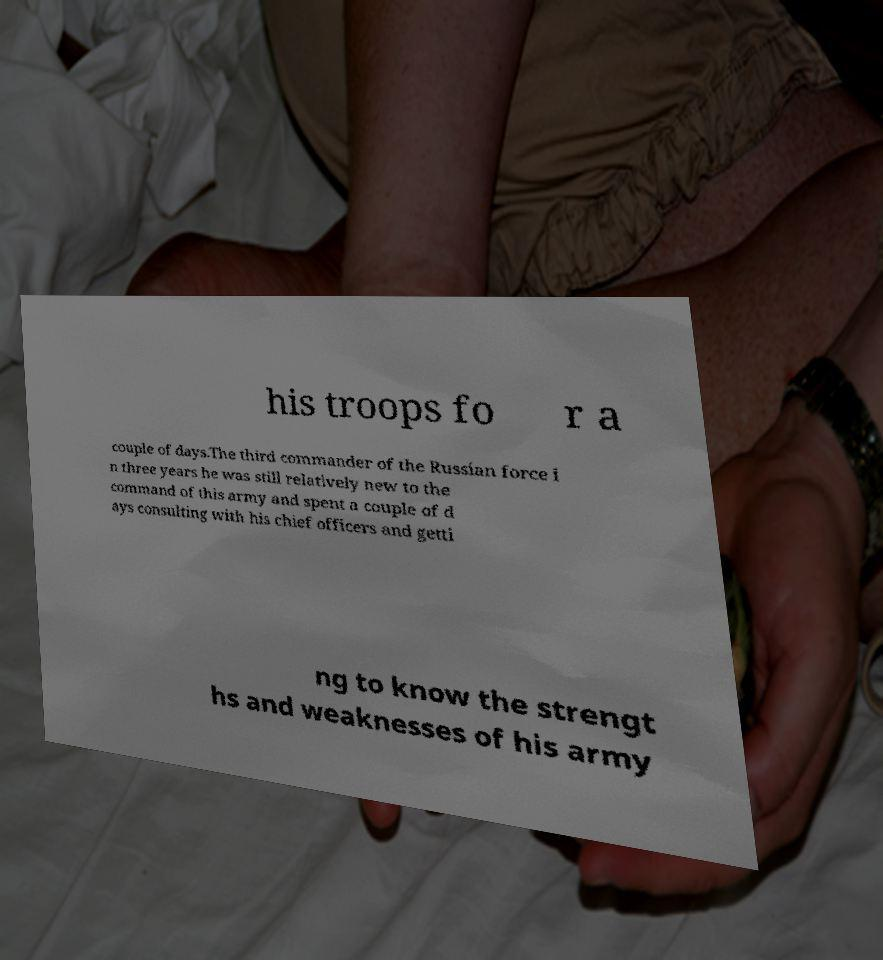Could you extract and type out the text from this image? his troops fo r a couple of days.The third commander of the Russian force i n three years he was still relatively new to the command of this army and spent a couple of d ays consulting with his chief officers and getti ng to know the strengt hs and weaknesses of his army 